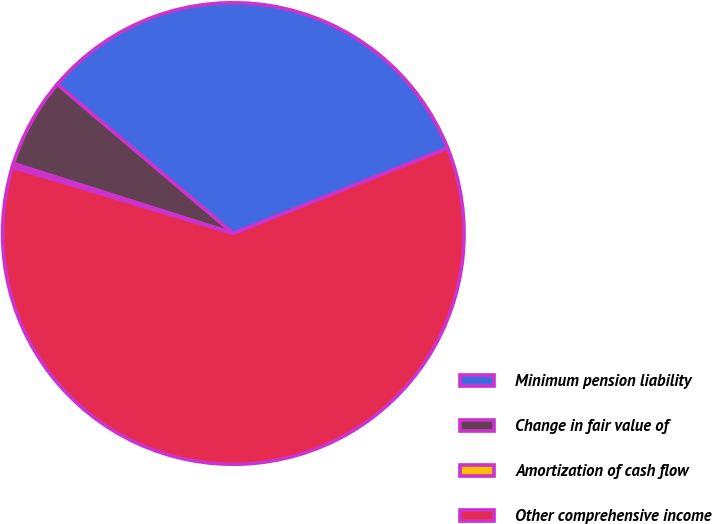Convert chart to OTSL. <chart><loc_0><loc_0><loc_500><loc_500><pie_chart><fcel>Minimum pension liability<fcel>Change in fair value of<fcel>Amortization of cash flow<fcel>Other comprehensive income<nl><fcel>32.78%<fcel>6.29%<fcel>0.25%<fcel>60.67%<nl></chart> 